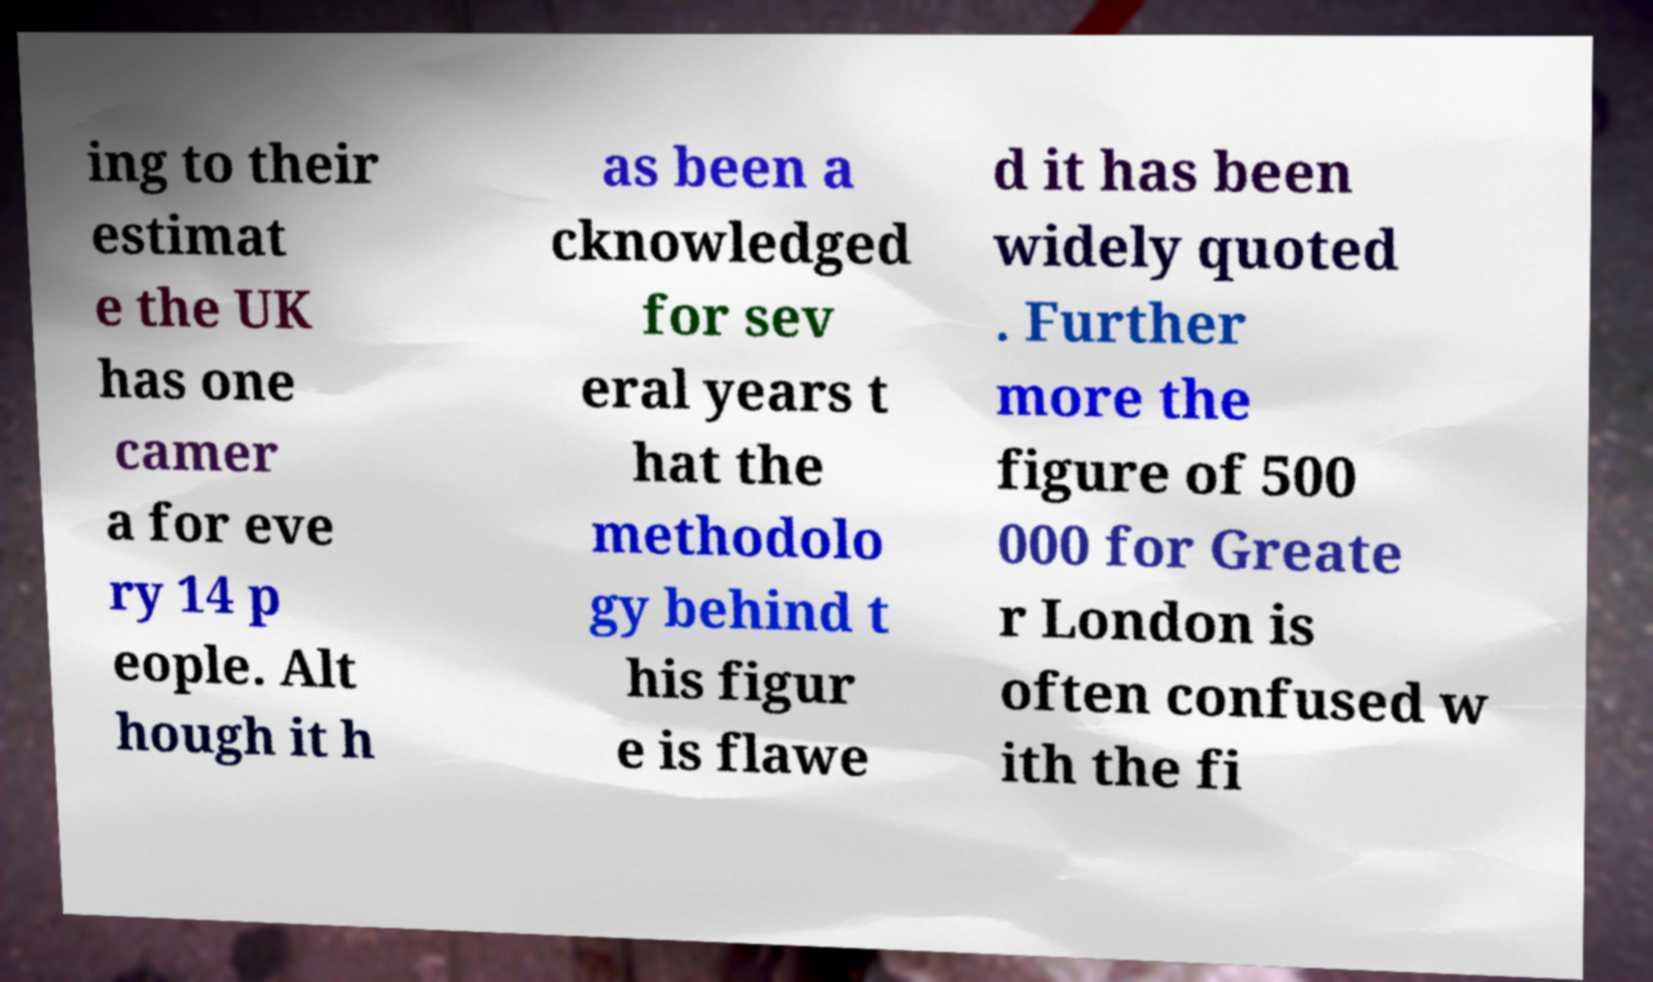Could you extract and type out the text from this image? ing to their estimat e the UK has one camer a for eve ry 14 p eople. Alt hough it h as been a cknowledged for sev eral years t hat the methodolo gy behind t his figur e is flawe d it has been widely quoted . Further more the figure of 500 000 for Greate r London is often confused w ith the fi 